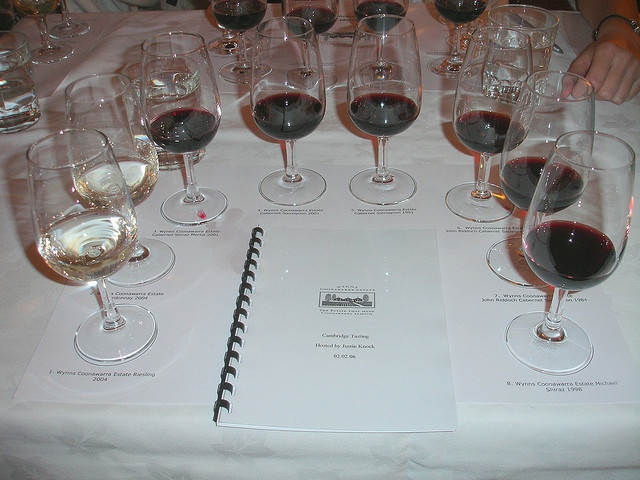Describe the objects in this image and their specific colors. I can see book in black, lightgray, and darkgray tones, wine glass in black, darkgray, gray, and lightgray tones, wine glass in black, gray, darkgray, and lightgray tones, wine glass in black, gray, and darkgray tones, and wine glass in black, gray, darkgray, and maroon tones in this image. 